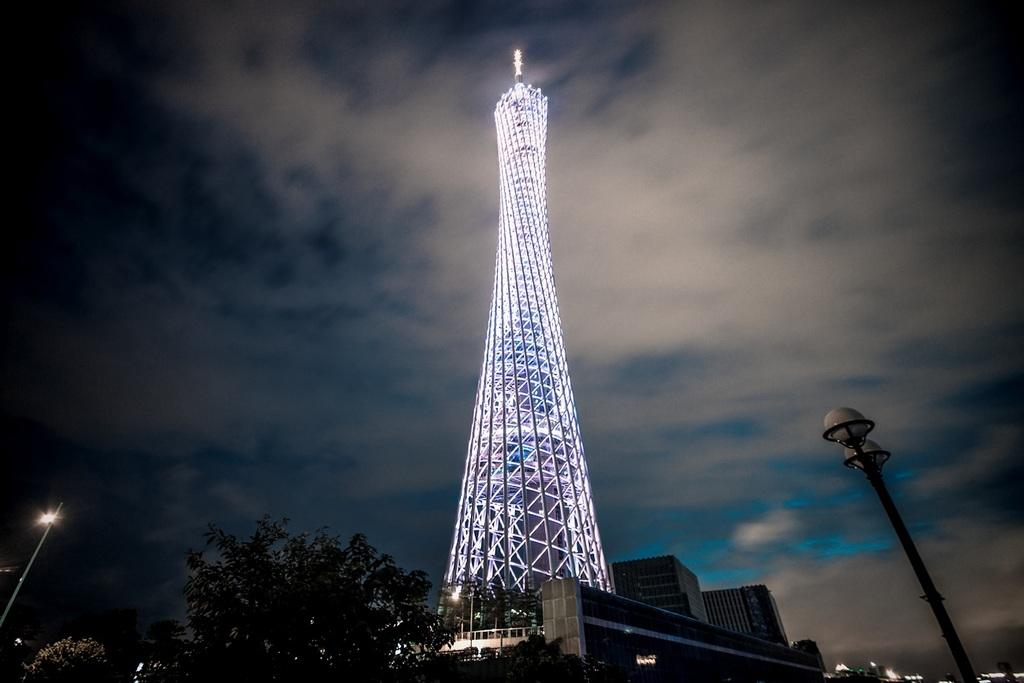What is the main structure in the center of the image? There is a tower with lights in the center of the image. What other types of structures can be seen in the image? There are buildings in the image. What natural elements are present in the image? There are trees in the image. What man-made objects are present in the image? There are poles and street lights in the image. What is visible in the sky in the image? There are clouds visible at the top of the image. What question does the mom ask in the image? There is no mom present in the image, so no question can be attributed to her. 